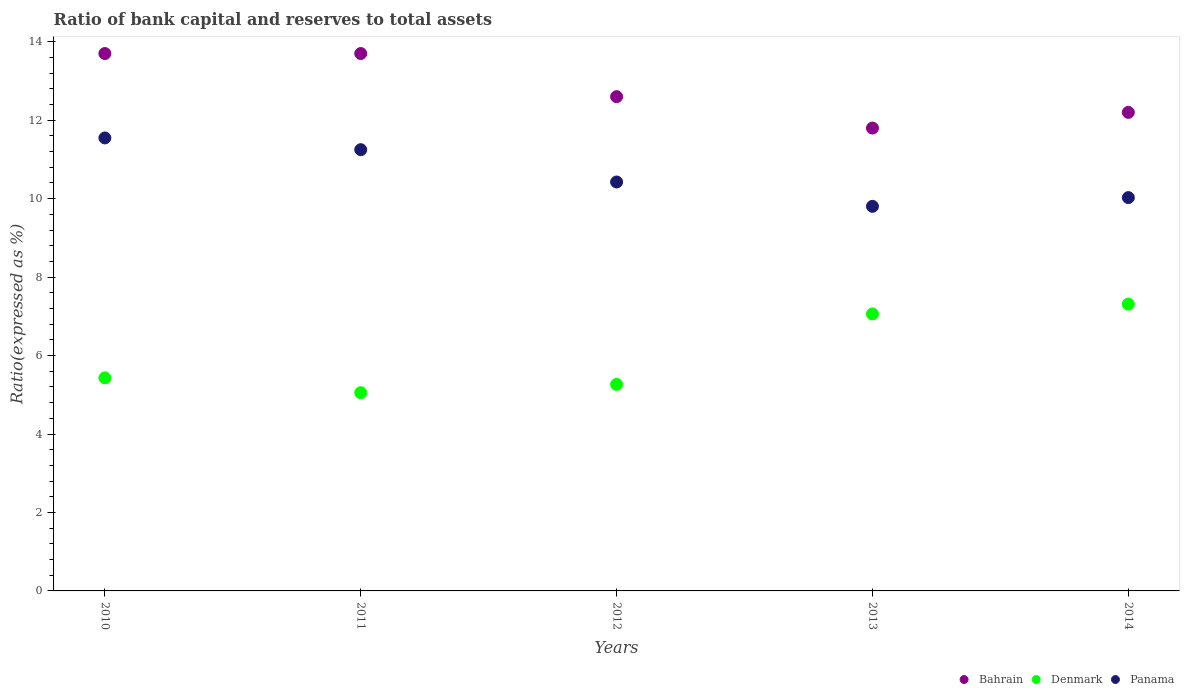Is the number of dotlines equal to the number of legend labels?
Keep it short and to the point. Yes. What is the ratio of bank capital and reserves to total assets in Denmark in 2010?
Provide a succinct answer. 5.43. Across all years, what is the maximum ratio of bank capital and reserves to total assets in Denmark?
Give a very brief answer. 7.31. In which year was the ratio of bank capital and reserves to total assets in Bahrain minimum?
Your answer should be compact. 2013. What is the total ratio of bank capital and reserves to total assets in Panama in the graph?
Your answer should be compact. 53.05. What is the difference between the ratio of bank capital and reserves to total assets in Bahrain in 2010 and that in 2012?
Offer a terse response. 1.1. What is the difference between the ratio of bank capital and reserves to total assets in Bahrain in 2013 and the ratio of bank capital and reserves to total assets in Denmark in 2012?
Your response must be concise. 6.53. What is the average ratio of bank capital and reserves to total assets in Bahrain per year?
Make the answer very short. 12.8. In the year 2010, what is the difference between the ratio of bank capital and reserves to total assets in Denmark and ratio of bank capital and reserves to total assets in Panama?
Your answer should be compact. -6.12. What is the ratio of the ratio of bank capital and reserves to total assets in Bahrain in 2010 to that in 2014?
Your answer should be very brief. 1.12. Is the difference between the ratio of bank capital and reserves to total assets in Denmark in 2011 and 2013 greater than the difference between the ratio of bank capital and reserves to total assets in Panama in 2011 and 2013?
Provide a succinct answer. No. What is the difference between the highest and the second highest ratio of bank capital and reserves to total assets in Panama?
Your response must be concise. 0.3. What is the difference between the highest and the lowest ratio of bank capital and reserves to total assets in Bahrain?
Keep it short and to the point. 1.9. In how many years, is the ratio of bank capital and reserves to total assets in Bahrain greater than the average ratio of bank capital and reserves to total assets in Bahrain taken over all years?
Provide a short and direct response. 2. Is the sum of the ratio of bank capital and reserves to total assets in Panama in 2010 and 2012 greater than the maximum ratio of bank capital and reserves to total assets in Denmark across all years?
Your answer should be very brief. Yes. Is the ratio of bank capital and reserves to total assets in Panama strictly less than the ratio of bank capital and reserves to total assets in Denmark over the years?
Your answer should be compact. No. How many dotlines are there?
Provide a succinct answer. 3. How many years are there in the graph?
Make the answer very short. 5. Does the graph contain any zero values?
Give a very brief answer. No. How many legend labels are there?
Make the answer very short. 3. What is the title of the graph?
Make the answer very short. Ratio of bank capital and reserves to total assets. What is the label or title of the X-axis?
Provide a short and direct response. Years. What is the label or title of the Y-axis?
Provide a succinct answer. Ratio(expressed as %). What is the Ratio(expressed as %) of Bahrain in 2010?
Provide a short and direct response. 13.7. What is the Ratio(expressed as %) in Denmark in 2010?
Make the answer very short. 5.43. What is the Ratio(expressed as %) of Panama in 2010?
Provide a short and direct response. 11.55. What is the Ratio(expressed as %) of Denmark in 2011?
Make the answer very short. 5.05. What is the Ratio(expressed as %) in Panama in 2011?
Your response must be concise. 11.25. What is the Ratio(expressed as %) of Bahrain in 2012?
Ensure brevity in your answer.  12.6. What is the Ratio(expressed as %) in Denmark in 2012?
Offer a terse response. 5.27. What is the Ratio(expressed as %) of Panama in 2012?
Keep it short and to the point. 10.42. What is the Ratio(expressed as %) of Denmark in 2013?
Provide a short and direct response. 7.06. What is the Ratio(expressed as %) in Panama in 2013?
Ensure brevity in your answer.  9.8. What is the Ratio(expressed as %) in Bahrain in 2014?
Provide a short and direct response. 12.2. What is the Ratio(expressed as %) in Denmark in 2014?
Offer a terse response. 7.31. What is the Ratio(expressed as %) of Panama in 2014?
Offer a very short reply. 10.03. Across all years, what is the maximum Ratio(expressed as %) in Bahrain?
Offer a terse response. 13.7. Across all years, what is the maximum Ratio(expressed as %) of Denmark?
Give a very brief answer. 7.31. Across all years, what is the maximum Ratio(expressed as %) of Panama?
Make the answer very short. 11.55. Across all years, what is the minimum Ratio(expressed as %) of Denmark?
Provide a short and direct response. 5.05. Across all years, what is the minimum Ratio(expressed as %) in Panama?
Your response must be concise. 9.8. What is the total Ratio(expressed as %) in Denmark in the graph?
Provide a short and direct response. 30.13. What is the total Ratio(expressed as %) in Panama in the graph?
Your answer should be very brief. 53.05. What is the difference between the Ratio(expressed as %) in Bahrain in 2010 and that in 2011?
Keep it short and to the point. 0. What is the difference between the Ratio(expressed as %) of Denmark in 2010 and that in 2011?
Ensure brevity in your answer.  0.38. What is the difference between the Ratio(expressed as %) in Panama in 2010 and that in 2011?
Offer a very short reply. 0.3. What is the difference between the Ratio(expressed as %) of Denmark in 2010 and that in 2012?
Ensure brevity in your answer.  0.17. What is the difference between the Ratio(expressed as %) in Panama in 2010 and that in 2012?
Keep it short and to the point. 1.12. What is the difference between the Ratio(expressed as %) in Bahrain in 2010 and that in 2013?
Keep it short and to the point. 1.9. What is the difference between the Ratio(expressed as %) in Denmark in 2010 and that in 2013?
Your response must be concise. -1.63. What is the difference between the Ratio(expressed as %) in Panama in 2010 and that in 2013?
Your answer should be compact. 1.74. What is the difference between the Ratio(expressed as %) in Bahrain in 2010 and that in 2014?
Keep it short and to the point. 1.5. What is the difference between the Ratio(expressed as %) of Denmark in 2010 and that in 2014?
Your response must be concise. -1.88. What is the difference between the Ratio(expressed as %) in Panama in 2010 and that in 2014?
Ensure brevity in your answer.  1.52. What is the difference between the Ratio(expressed as %) of Bahrain in 2011 and that in 2012?
Give a very brief answer. 1.1. What is the difference between the Ratio(expressed as %) in Denmark in 2011 and that in 2012?
Provide a short and direct response. -0.21. What is the difference between the Ratio(expressed as %) in Panama in 2011 and that in 2012?
Keep it short and to the point. 0.82. What is the difference between the Ratio(expressed as %) in Bahrain in 2011 and that in 2013?
Your answer should be compact. 1.9. What is the difference between the Ratio(expressed as %) in Denmark in 2011 and that in 2013?
Your response must be concise. -2.01. What is the difference between the Ratio(expressed as %) of Panama in 2011 and that in 2013?
Offer a terse response. 1.44. What is the difference between the Ratio(expressed as %) in Bahrain in 2011 and that in 2014?
Your response must be concise. 1.5. What is the difference between the Ratio(expressed as %) in Denmark in 2011 and that in 2014?
Your answer should be very brief. -2.26. What is the difference between the Ratio(expressed as %) in Panama in 2011 and that in 2014?
Give a very brief answer. 1.22. What is the difference between the Ratio(expressed as %) in Denmark in 2012 and that in 2013?
Provide a short and direct response. -1.8. What is the difference between the Ratio(expressed as %) of Panama in 2012 and that in 2013?
Provide a succinct answer. 0.62. What is the difference between the Ratio(expressed as %) of Bahrain in 2012 and that in 2014?
Provide a succinct answer. 0.4. What is the difference between the Ratio(expressed as %) of Denmark in 2012 and that in 2014?
Provide a short and direct response. -2.05. What is the difference between the Ratio(expressed as %) of Panama in 2012 and that in 2014?
Make the answer very short. 0.4. What is the difference between the Ratio(expressed as %) of Denmark in 2013 and that in 2014?
Your answer should be very brief. -0.25. What is the difference between the Ratio(expressed as %) of Panama in 2013 and that in 2014?
Give a very brief answer. -0.22. What is the difference between the Ratio(expressed as %) of Bahrain in 2010 and the Ratio(expressed as %) of Denmark in 2011?
Keep it short and to the point. 8.65. What is the difference between the Ratio(expressed as %) in Bahrain in 2010 and the Ratio(expressed as %) in Panama in 2011?
Offer a very short reply. 2.45. What is the difference between the Ratio(expressed as %) of Denmark in 2010 and the Ratio(expressed as %) of Panama in 2011?
Your answer should be very brief. -5.82. What is the difference between the Ratio(expressed as %) of Bahrain in 2010 and the Ratio(expressed as %) of Denmark in 2012?
Offer a very short reply. 8.43. What is the difference between the Ratio(expressed as %) in Bahrain in 2010 and the Ratio(expressed as %) in Panama in 2012?
Provide a succinct answer. 3.28. What is the difference between the Ratio(expressed as %) in Denmark in 2010 and the Ratio(expressed as %) in Panama in 2012?
Provide a short and direct response. -4.99. What is the difference between the Ratio(expressed as %) in Bahrain in 2010 and the Ratio(expressed as %) in Denmark in 2013?
Provide a short and direct response. 6.64. What is the difference between the Ratio(expressed as %) of Bahrain in 2010 and the Ratio(expressed as %) of Panama in 2013?
Offer a terse response. 3.9. What is the difference between the Ratio(expressed as %) of Denmark in 2010 and the Ratio(expressed as %) of Panama in 2013?
Provide a short and direct response. -4.37. What is the difference between the Ratio(expressed as %) in Bahrain in 2010 and the Ratio(expressed as %) in Denmark in 2014?
Your answer should be compact. 6.39. What is the difference between the Ratio(expressed as %) in Bahrain in 2010 and the Ratio(expressed as %) in Panama in 2014?
Your answer should be very brief. 3.67. What is the difference between the Ratio(expressed as %) of Denmark in 2010 and the Ratio(expressed as %) of Panama in 2014?
Give a very brief answer. -4.59. What is the difference between the Ratio(expressed as %) of Bahrain in 2011 and the Ratio(expressed as %) of Denmark in 2012?
Your answer should be very brief. 8.43. What is the difference between the Ratio(expressed as %) in Bahrain in 2011 and the Ratio(expressed as %) in Panama in 2012?
Provide a short and direct response. 3.28. What is the difference between the Ratio(expressed as %) of Denmark in 2011 and the Ratio(expressed as %) of Panama in 2012?
Offer a very short reply. -5.37. What is the difference between the Ratio(expressed as %) in Bahrain in 2011 and the Ratio(expressed as %) in Denmark in 2013?
Offer a very short reply. 6.64. What is the difference between the Ratio(expressed as %) in Bahrain in 2011 and the Ratio(expressed as %) in Panama in 2013?
Offer a very short reply. 3.9. What is the difference between the Ratio(expressed as %) in Denmark in 2011 and the Ratio(expressed as %) in Panama in 2013?
Ensure brevity in your answer.  -4.75. What is the difference between the Ratio(expressed as %) of Bahrain in 2011 and the Ratio(expressed as %) of Denmark in 2014?
Your answer should be compact. 6.39. What is the difference between the Ratio(expressed as %) in Bahrain in 2011 and the Ratio(expressed as %) in Panama in 2014?
Offer a very short reply. 3.67. What is the difference between the Ratio(expressed as %) in Denmark in 2011 and the Ratio(expressed as %) in Panama in 2014?
Make the answer very short. -4.97. What is the difference between the Ratio(expressed as %) in Bahrain in 2012 and the Ratio(expressed as %) in Denmark in 2013?
Offer a very short reply. 5.54. What is the difference between the Ratio(expressed as %) of Bahrain in 2012 and the Ratio(expressed as %) of Panama in 2013?
Ensure brevity in your answer.  2.8. What is the difference between the Ratio(expressed as %) of Denmark in 2012 and the Ratio(expressed as %) of Panama in 2013?
Your answer should be very brief. -4.54. What is the difference between the Ratio(expressed as %) in Bahrain in 2012 and the Ratio(expressed as %) in Denmark in 2014?
Keep it short and to the point. 5.29. What is the difference between the Ratio(expressed as %) in Bahrain in 2012 and the Ratio(expressed as %) in Panama in 2014?
Keep it short and to the point. 2.57. What is the difference between the Ratio(expressed as %) of Denmark in 2012 and the Ratio(expressed as %) of Panama in 2014?
Your response must be concise. -4.76. What is the difference between the Ratio(expressed as %) in Bahrain in 2013 and the Ratio(expressed as %) in Denmark in 2014?
Ensure brevity in your answer.  4.49. What is the difference between the Ratio(expressed as %) of Bahrain in 2013 and the Ratio(expressed as %) of Panama in 2014?
Offer a very short reply. 1.77. What is the difference between the Ratio(expressed as %) in Denmark in 2013 and the Ratio(expressed as %) in Panama in 2014?
Your answer should be compact. -2.97. What is the average Ratio(expressed as %) in Denmark per year?
Provide a short and direct response. 6.03. What is the average Ratio(expressed as %) of Panama per year?
Offer a very short reply. 10.61. In the year 2010, what is the difference between the Ratio(expressed as %) of Bahrain and Ratio(expressed as %) of Denmark?
Give a very brief answer. 8.27. In the year 2010, what is the difference between the Ratio(expressed as %) of Bahrain and Ratio(expressed as %) of Panama?
Give a very brief answer. 2.15. In the year 2010, what is the difference between the Ratio(expressed as %) in Denmark and Ratio(expressed as %) in Panama?
Offer a very short reply. -6.12. In the year 2011, what is the difference between the Ratio(expressed as %) of Bahrain and Ratio(expressed as %) of Denmark?
Provide a short and direct response. 8.65. In the year 2011, what is the difference between the Ratio(expressed as %) in Bahrain and Ratio(expressed as %) in Panama?
Offer a very short reply. 2.45. In the year 2011, what is the difference between the Ratio(expressed as %) of Denmark and Ratio(expressed as %) of Panama?
Offer a terse response. -6.2. In the year 2012, what is the difference between the Ratio(expressed as %) in Bahrain and Ratio(expressed as %) in Denmark?
Your response must be concise. 7.33. In the year 2012, what is the difference between the Ratio(expressed as %) of Bahrain and Ratio(expressed as %) of Panama?
Your response must be concise. 2.18. In the year 2012, what is the difference between the Ratio(expressed as %) of Denmark and Ratio(expressed as %) of Panama?
Offer a terse response. -5.16. In the year 2013, what is the difference between the Ratio(expressed as %) in Bahrain and Ratio(expressed as %) in Denmark?
Give a very brief answer. 4.74. In the year 2013, what is the difference between the Ratio(expressed as %) in Bahrain and Ratio(expressed as %) in Panama?
Your response must be concise. 2. In the year 2013, what is the difference between the Ratio(expressed as %) of Denmark and Ratio(expressed as %) of Panama?
Give a very brief answer. -2.74. In the year 2014, what is the difference between the Ratio(expressed as %) in Bahrain and Ratio(expressed as %) in Denmark?
Provide a succinct answer. 4.89. In the year 2014, what is the difference between the Ratio(expressed as %) of Bahrain and Ratio(expressed as %) of Panama?
Offer a very short reply. 2.17. In the year 2014, what is the difference between the Ratio(expressed as %) in Denmark and Ratio(expressed as %) in Panama?
Keep it short and to the point. -2.71. What is the ratio of the Ratio(expressed as %) in Denmark in 2010 to that in 2011?
Offer a terse response. 1.07. What is the ratio of the Ratio(expressed as %) of Panama in 2010 to that in 2011?
Make the answer very short. 1.03. What is the ratio of the Ratio(expressed as %) in Bahrain in 2010 to that in 2012?
Ensure brevity in your answer.  1.09. What is the ratio of the Ratio(expressed as %) of Denmark in 2010 to that in 2012?
Provide a short and direct response. 1.03. What is the ratio of the Ratio(expressed as %) in Panama in 2010 to that in 2012?
Make the answer very short. 1.11. What is the ratio of the Ratio(expressed as %) of Bahrain in 2010 to that in 2013?
Provide a succinct answer. 1.16. What is the ratio of the Ratio(expressed as %) in Denmark in 2010 to that in 2013?
Provide a short and direct response. 0.77. What is the ratio of the Ratio(expressed as %) of Panama in 2010 to that in 2013?
Provide a succinct answer. 1.18. What is the ratio of the Ratio(expressed as %) in Bahrain in 2010 to that in 2014?
Your response must be concise. 1.12. What is the ratio of the Ratio(expressed as %) of Denmark in 2010 to that in 2014?
Provide a succinct answer. 0.74. What is the ratio of the Ratio(expressed as %) in Panama in 2010 to that in 2014?
Ensure brevity in your answer.  1.15. What is the ratio of the Ratio(expressed as %) of Bahrain in 2011 to that in 2012?
Your answer should be compact. 1.09. What is the ratio of the Ratio(expressed as %) in Denmark in 2011 to that in 2012?
Make the answer very short. 0.96. What is the ratio of the Ratio(expressed as %) of Panama in 2011 to that in 2012?
Make the answer very short. 1.08. What is the ratio of the Ratio(expressed as %) of Bahrain in 2011 to that in 2013?
Provide a succinct answer. 1.16. What is the ratio of the Ratio(expressed as %) in Denmark in 2011 to that in 2013?
Your response must be concise. 0.72. What is the ratio of the Ratio(expressed as %) of Panama in 2011 to that in 2013?
Give a very brief answer. 1.15. What is the ratio of the Ratio(expressed as %) in Bahrain in 2011 to that in 2014?
Ensure brevity in your answer.  1.12. What is the ratio of the Ratio(expressed as %) of Denmark in 2011 to that in 2014?
Your response must be concise. 0.69. What is the ratio of the Ratio(expressed as %) of Panama in 2011 to that in 2014?
Provide a succinct answer. 1.12. What is the ratio of the Ratio(expressed as %) of Bahrain in 2012 to that in 2013?
Your response must be concise. 1.07. What is the ratio of the Ratio(expressed as %) of Denmark in 2012 to that in 2013?
Provide a short and direct response. 0.75. What is the ratio of the Ratio(expressed as %) of Panama in 2012 to that in 2013?
Ensure brevity in your answer.  1.06. What is the ratio of the Ratio(expressed as %) in Bahrain in 2012 to that in 2014?
Provide a succinct answer. 1.03. What is the ratio of the Ratio(expressed as %) in Denmark in 2012 to that in 2014?
Provide a short and direct response. 0.72. What is the ratio of the Ratio(expressed as %) of Panama in 2012 to that in 2014?
Give a very brief answer. 1.04. What is the ratio of the Ratio(expressed as %) of Bahrain in 2013 to that in 2014?
Provide a short and direct response. 0.97. What is the ratio of the Ratio(expressed as %) in Denmark in 2013 to that in 2014?
Provide a succinct answer. 0.97. What is the ratio of the Ratio(expressed as %) in Panama in 2013 to that in 2014?
Your answer should be very brief. 0.98. What is the difference between the highest and the second highest Ratio(expressed as %) in Bahrain?
Your answer should be compact. 0. What is the difference between the highest and the second highest Ratio(expressed as %) in Denmark?
Your answer should be very brief. 0.25. What is the difference between the highest and the second highest Ratio(expressed as %) of Panama?
Make the answer very short. 0.3. What is the difference between the highest and the lowest Ratio(expressed as %) in Denmark?
Offer a very short reply. 2.26. What is the difference between the highest and the lowest Ratio(expressed as %) in Panama?
Offer a very short reply. 1.74. 